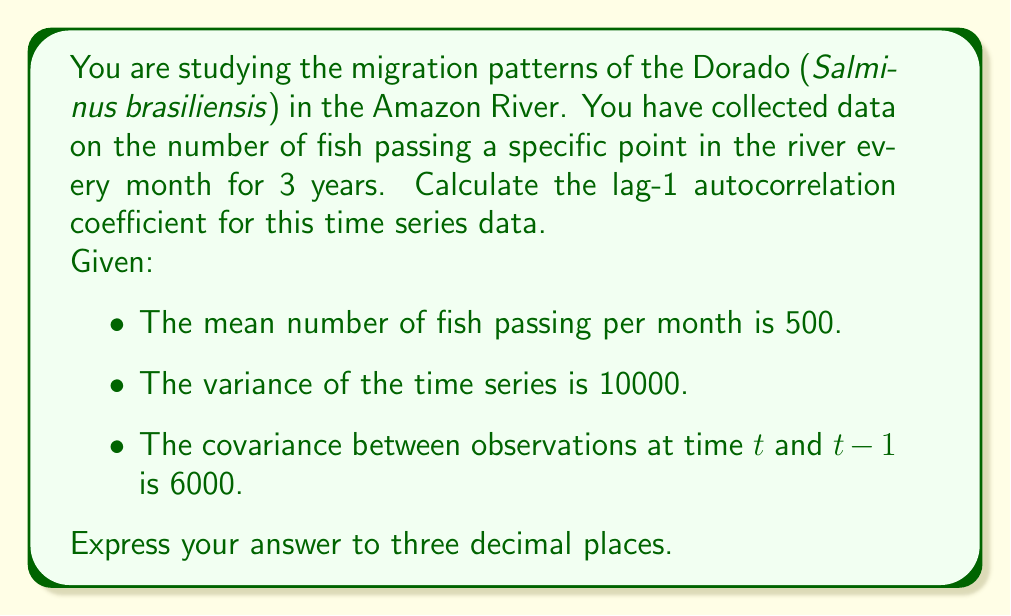Could you help me with this problem? To calculate the lag-1 autocorrelation coefficient, we'll use the following formula:

$$ r_1 = \frac{\text{Cov}(Y_t, Y_{t-1})}{\sqrt{\text{Var}(Y_t)\text{Var}(Y_{t-1})}} $$

Where:
- $r_1$ is the lag-1 autocorrelation coefficient
- $\text{Cov}(Y_t, Y_{t-1})$ is the covariance between observations at time t and t-1
- $\text{Var}(Y_t)$ and $\text{Var}(Y_{t-1})$ are the variances of the time series

Given:
- $\text{Cov}(Y_t, Y_{t-1}) = 6000$
- $\text{Var}(Y_t) = \text{Var}(Y_{t-1}) = 10000$ (assuming stationarity)

Substituting these values into the formula:

$$ r_1 = \frac{6000}{\sqrt{10000 \cdot 10000}} $$

$$ r_1 = \frac{6000}{10000} $$

$$ r_1 = 0.6 $$

Therefore, the lag-1 autocorrelation coefficient is 0.600 to three decimal places.
Answer: 0.600 